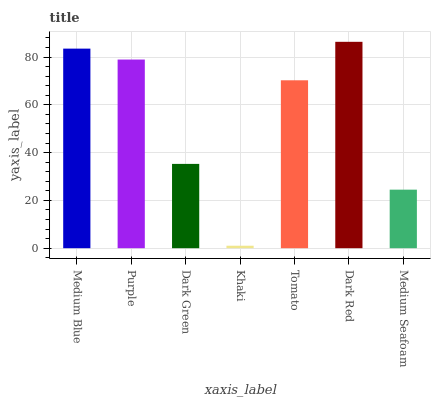Is Khaki the minimum?
Answer yes or no. Yes. Is Dark Red the maximum?
Answer yes or no. Yes. Is Purple the minimum?
Answer yes or no. No. Is Purple the maximum?
Answer yes or no. No. Is Medium Blue greater than Purple?
Answer yes or no. Yes. Is Purple less than Medium Blue?
Answer yes or no. Yes. Is Purple greater than Medium Blue?
Answer yes or no. No. Is Medium Blue less than Purple?
Answer yes or no. No. Is Tomato the high median?
Answer yes or no. Yes. Is Tomato the low median?
Answer yes or no. Yes. Is Dark Red the high median?
Answer yes or no. No. Is Medium Blue the low median?
Answer yes or no. No. 